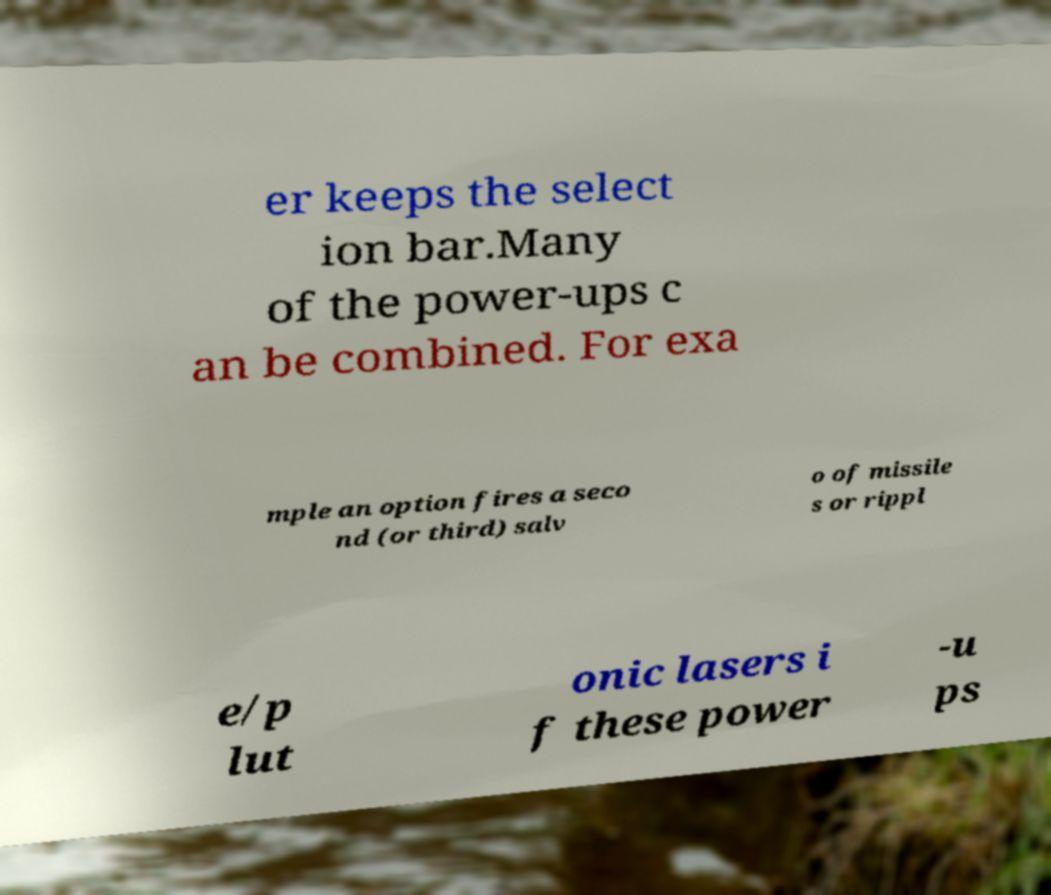Could you assist in decoding the text presented in this image and type it out clearly? er keeps the select ion bar.Many of the power-ups c an be combined. For exa mple an option fires a seco nd (or third) salv o of missile s or rippl e/p lut onic lasers i f these power -u ps 